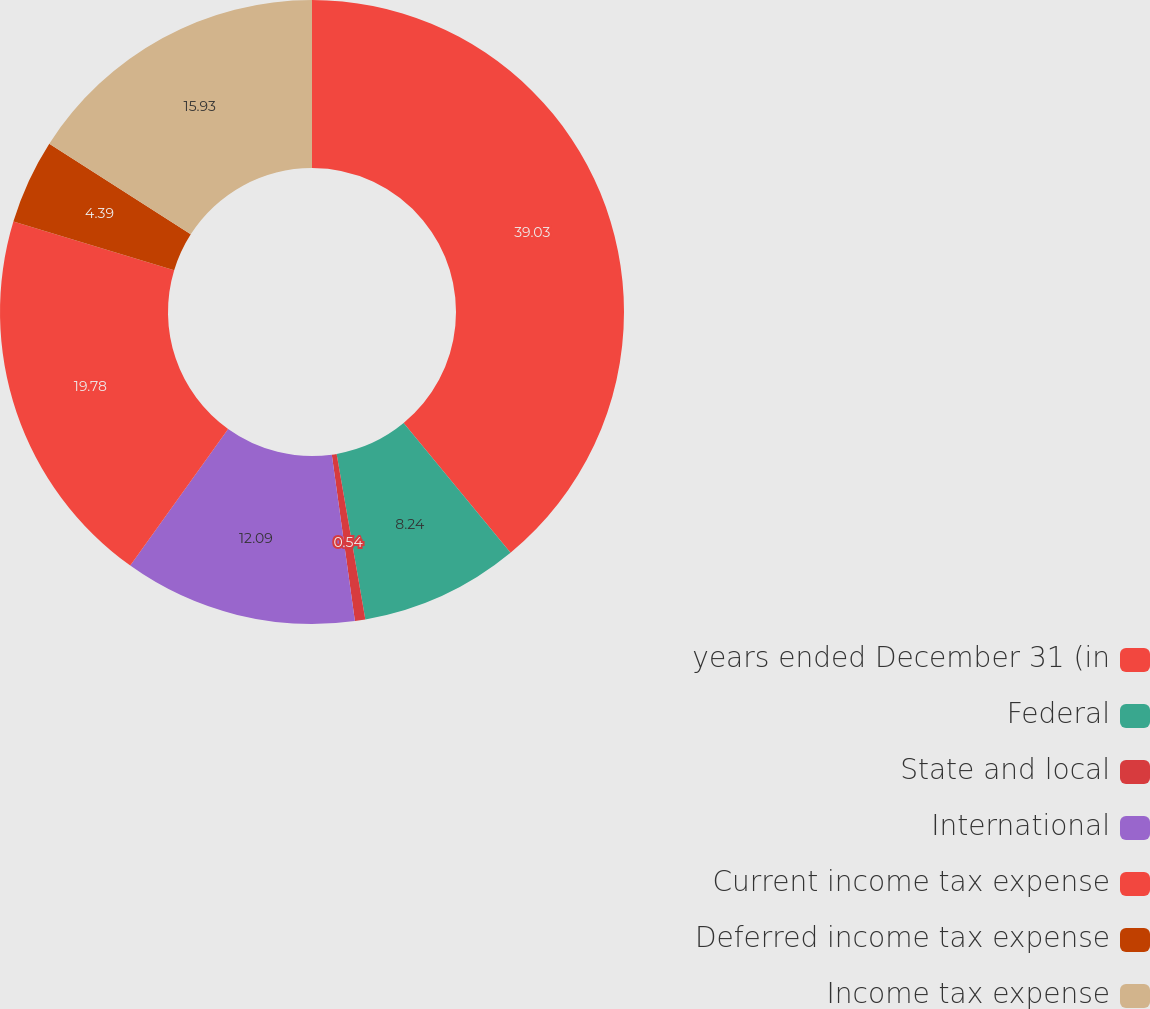Convert chart to OTSL. <chart><loc_0><loc_0><loc_500><loc_500><pie_chart><fcel>years ended December 31 (in<fcel>Federal<fcel>State and local<fcel>International<fcel>Current income tax expense<fcel>Deferred income tax expense<fcel>Income tax expense<nl><fcel>39.02%<fcel>8.24%<fcel>0.54%<fcel>12.09%<fcel>19.78%<fcel>4.39%<fcel>15.93%<nl></chart> 